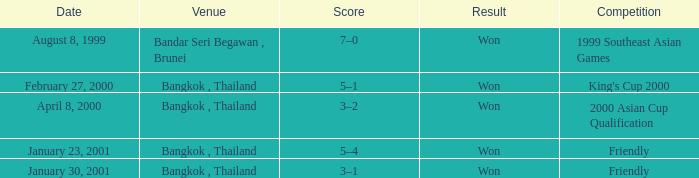Help me parse the entirety of this table. {'header': ['Date', 'Venue', 'Score', 'Result', 'Competition'], 'rows': [['August 8, 1999', 'Bandar Seri Begawan , Brunei', '7–0', 'Won', '1999 Southeast Asian Games'], ['February 27, 2000', 'Bangkok , Thailand', '5–1', 'Won', "King's Cup 2000"], ['April 8, 2000', 'Bangkok , Thailand', '3–2', 'Won', '2000 Asian Cup Qualification'], ['January 23, 2001', 'Bangkok , Thailand', '5–4', 'Won', 'Friendly'], ['January 30, 2001', 'Bangkok , Thailand', '3–1', 'Won', 'Friendly']]} On what date was the game that had a score of 7–0? August 8, 1999. 